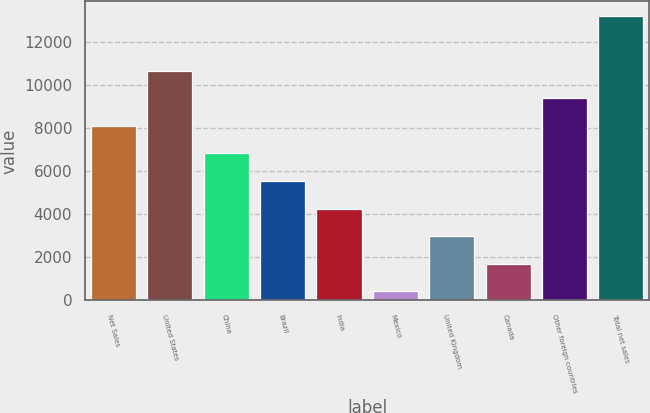<chart> <loc_0><loc_0><loc_500><loc_500><bar_chart><fcel>Net Sales<fcel>United States<fcel>China<fcel>Brazil<fcel>India<fcel>Mexico<fcel>United Kingdom<fcel>Canada<fcel>Other foreign countries<fcel>Total net sales<nl><fcel>8101.6<fcel>10663.8<fcel>6820.5<fcel>5539.4<fcel>4258.3<fcel>415<fcel>2977.2<fcel>1696.1<fcel>9382.7<fcel>13226<nl></chart> 